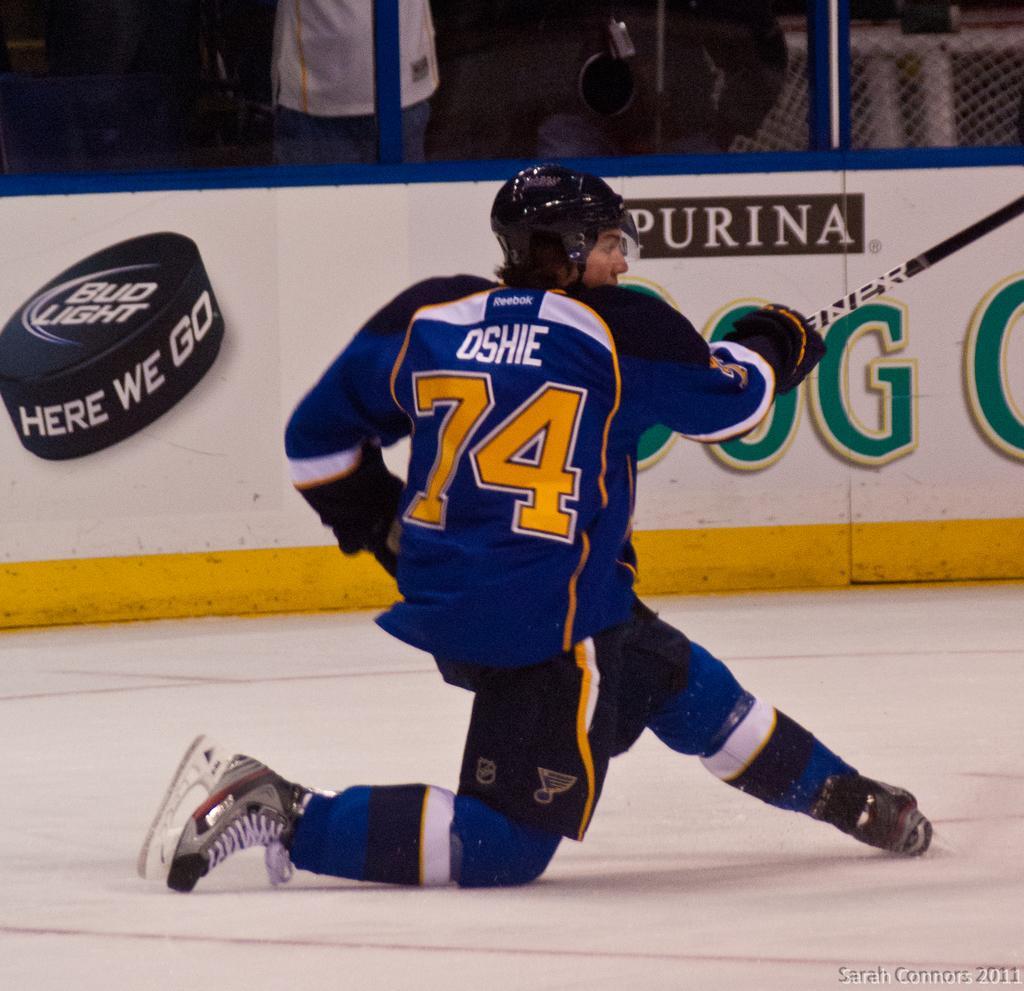Could you give a brief overview of what you see in this image? The man in the middle of the picture wearing a blue T-shirt and a black helmet is holding a hockey stick in his hand. He might be playing the hockey. Behind him, we see a white board with some text written on it. Behind that, we see a fence. Behind that, we see people are sitting on the chairs. Beside that, the man in white T-shirt is standing. This picture might be clicked in the indoor stadium. 